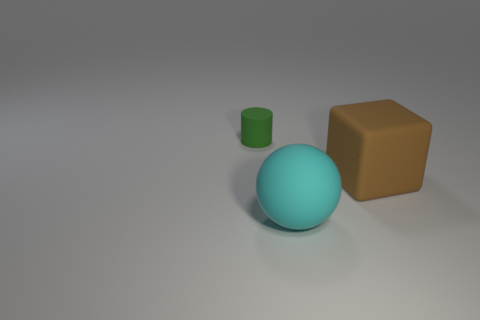Add 3 large cyan objects. How many objects exist? 6 Subtract all balls. How many objects are left? 2 Subtract 0 blue cubes. How many objects are left? 3 Subtract all big cubes. Subtract all matte blocks. How many objects are left? 1 Add 3 large cubes. How many large cubes are left? 4 Add 3 small matte objects. How many small matte objects exist? 4 